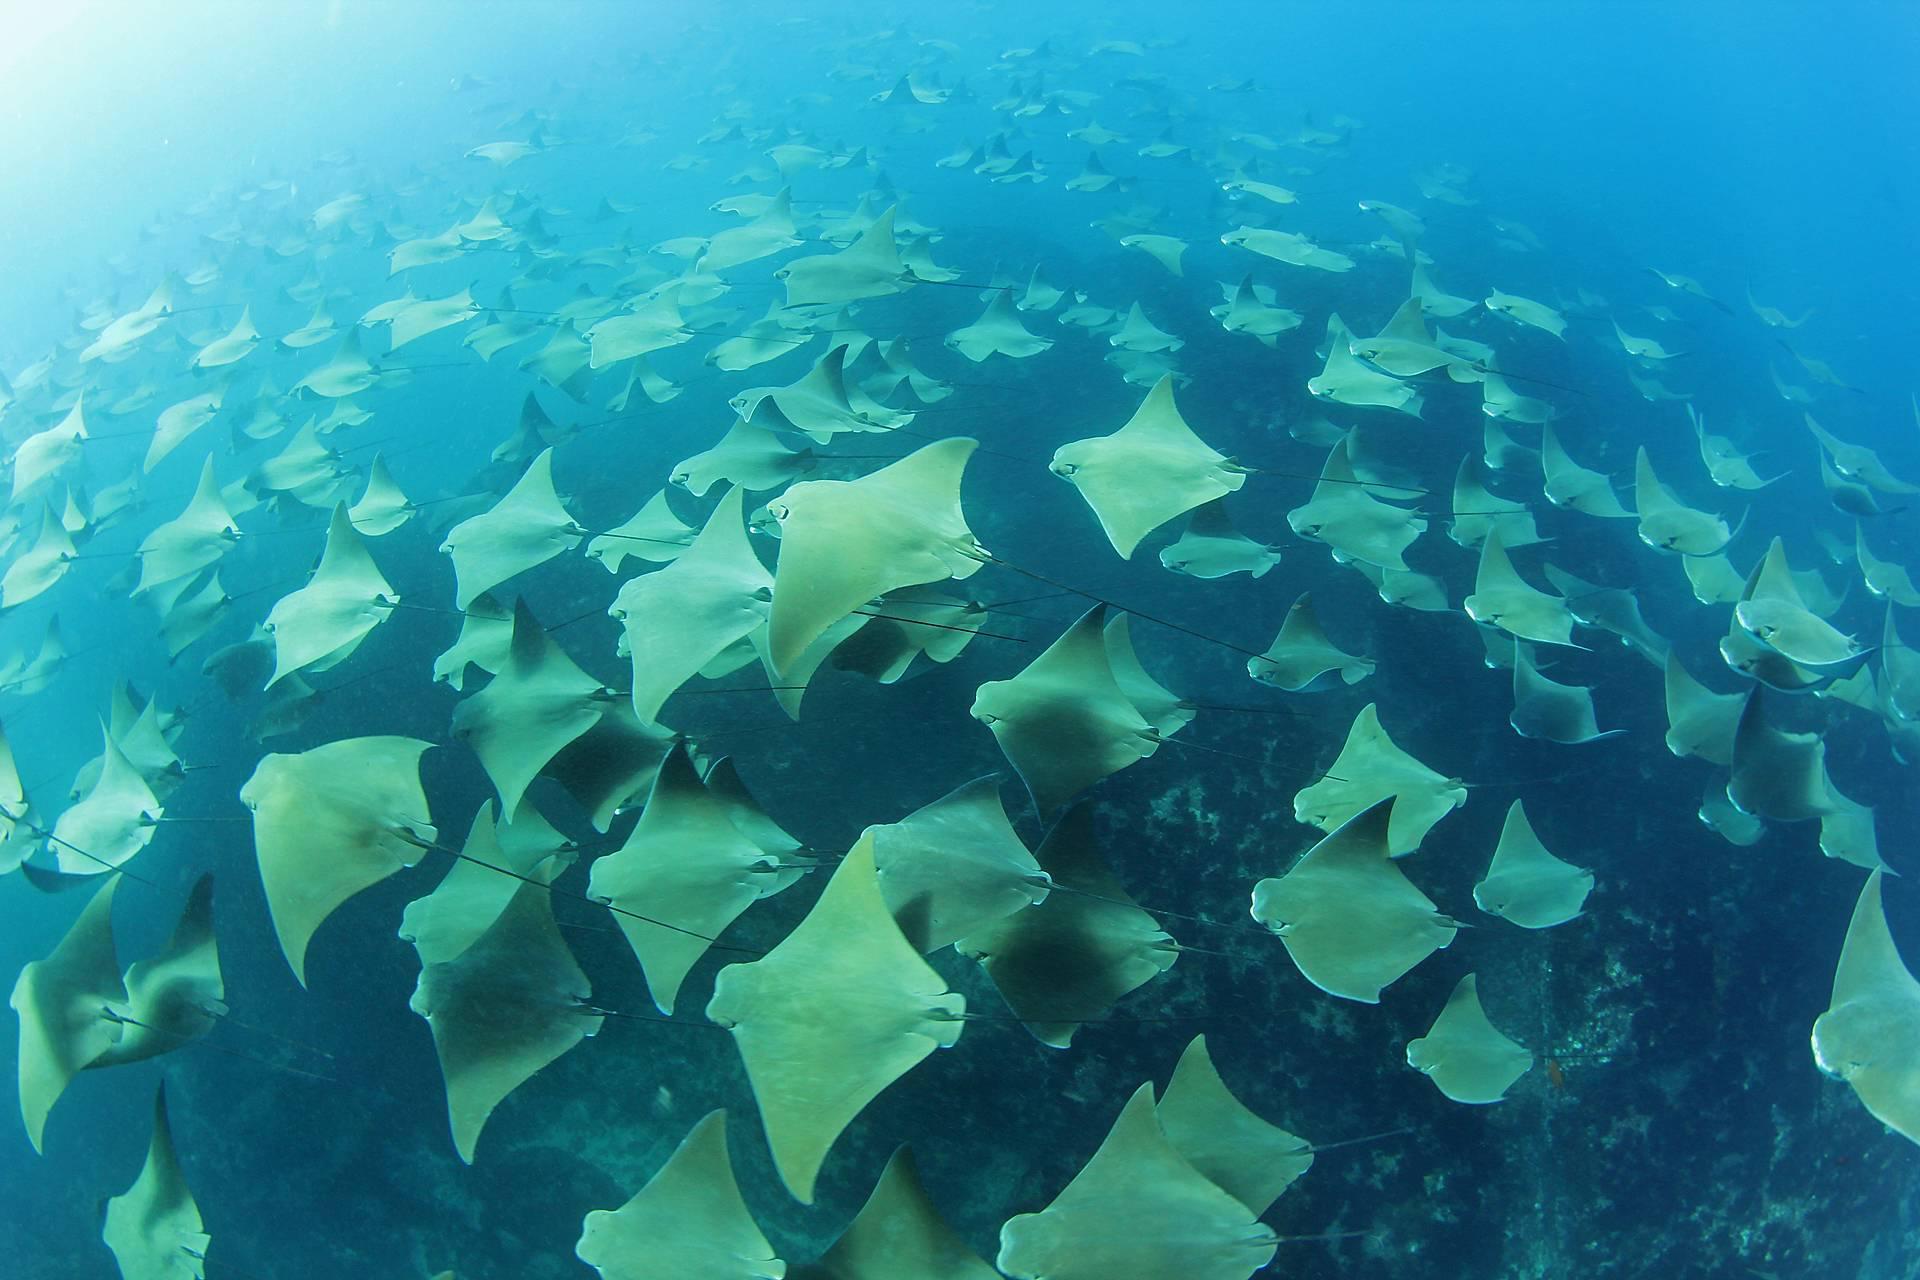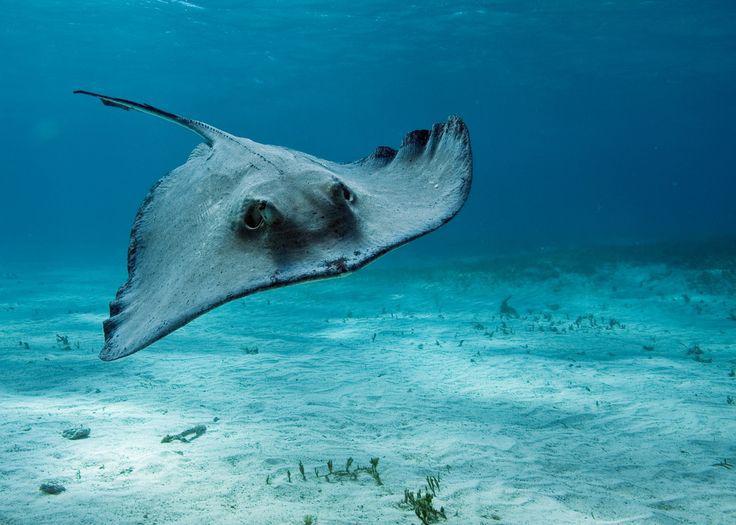The first image is the image on the left, the second image is the image on the right. Assess this claim about the two images: "At least one image in the pair shows a single stingray.". Correct or not? Answer yes or no. Yes. The first image is the image on the left, the second image is the image on the right. Considering the images on both sides, is "the left image shows a sea full of stingray from the top view" valid? Answer yes or no. Yes. 